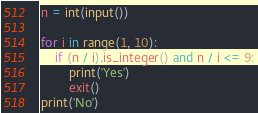<code> <loc_0><loc_0><loc_500><loc_500><_Python_>n = int(input())

for i in range(1, 10):
    if (n / i).is_integer() and n / i <= 9:
        print('Yes')
        exit()
print('No')
</code> 